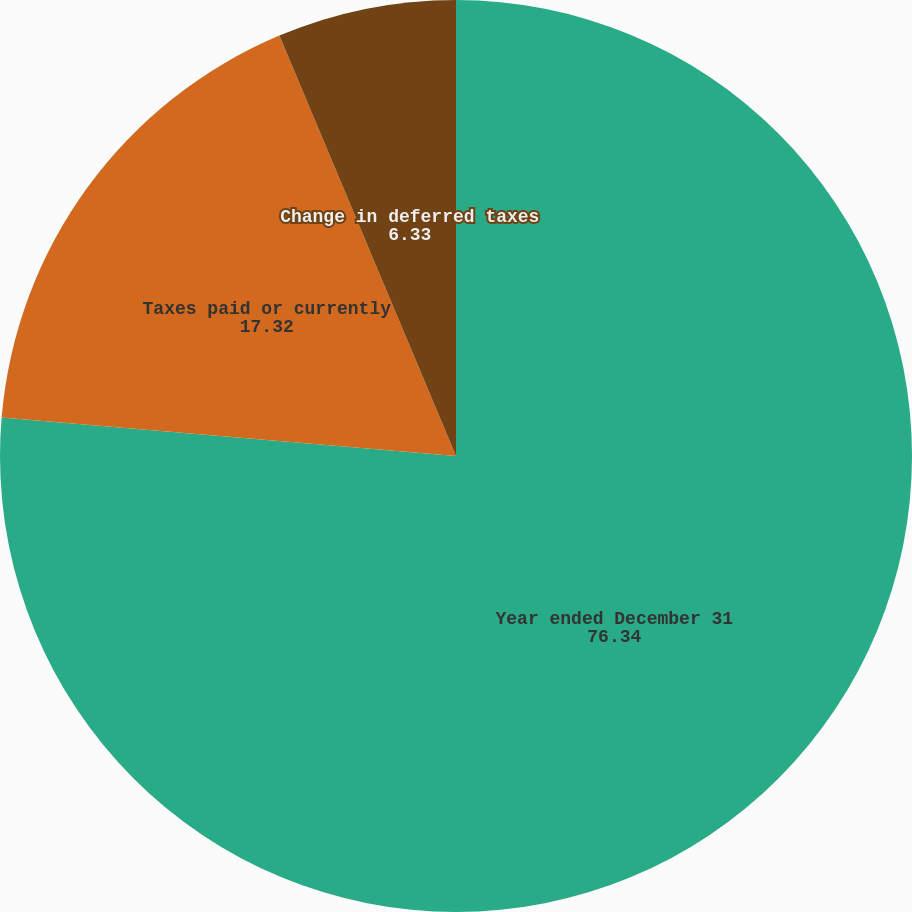<chart> <loc_0><loc_0><loc_500><loc_500><pie_chart><fcel>Year ended December 31<fcel>Taxes paid or currently<fcel>Change in deferred taxes<nl><fcel>76.34%<fcel>17.32%<fcel>6.33%<nl></chart> 